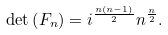Convert formula to latex. <formula><loc_0><loc_0><loc_500><loc_500>\det \left ( F _ { n } \right ) = i ^ { \frac { n ( n - 1 ) } { 2 } } n ^ { \frac { n } { 2 } } .</formula> 